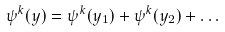Convert formula to latex. <formula><loc_0><loc_0><loc_500><loc_500>\psi ^ { k } ( y ) = \psi ^ { k } ( y _ { 1 } ) + \psi ^ { k } ( y _ { 2 } ) + \dots</formula> 